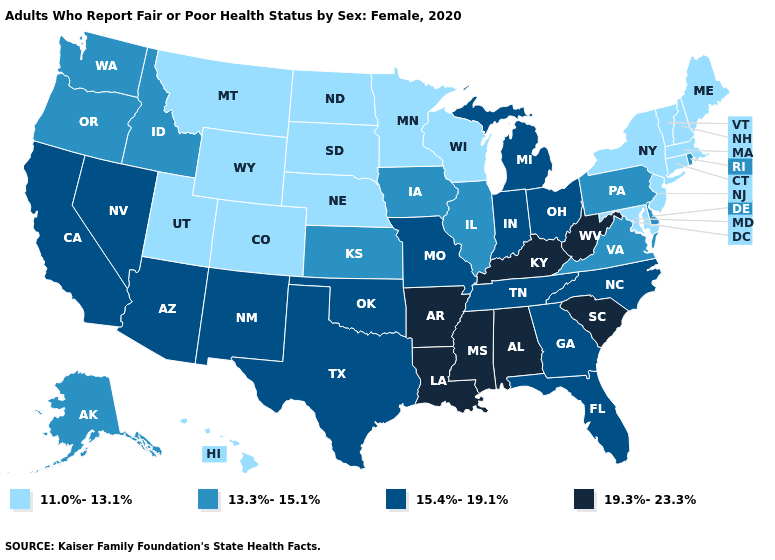Among the states that border Alabama , does Mississippi have the highest value?
Write a very short answer. Yes. Does Nebraska have the highest value in the USA?
Give a very brief answer. No. Does Rhode Island have the highest value in the Northeast?
Be succinct. Yes. What is the highest value in states that border Tennessee?
Quick response, please. 19.3%-23.3%. Does South Carolina have the highest value in the South?
Be succinct. Yes. Which states have the lowest value in the West?
Concise answer only. Colorado, Hawaii, Montana, Utah, Wyoming. What is the highest value in the West ?
Write a very short answer. 15.4%-19.1%. What is the highest value in the Northeast ?
Give a very brief answer. 13.3%-15.1%. Name the states that have a value in the range 19.3%-23.3%?
Answer briefly. Alabama, Arkansas, Kentucky, Louisiana, Mississippi, South Carolina, West Virginia. How many symbols are there in the legend?
Write a very short answer. 4. Name the states that have a value in the range 19.3%-23.3%?
Quick response, please. Alabama, Arkansas, Kentucky, Louisiana, Mississippi, South Carolina, West Virginia. Name the states that have a value in the range 19.3%-23.3%?
Short answer required. Alabama, Arkansas, Kentucky, Louisiana, Mississippi, South Carolina, West Virginia. Name the states that have a value in the range 19.3%-23.3%?
Give a very brief answer. Alabama, Arkansas, Kentucky, Louisiana, Mississippi, South Carolina, West Virginia. What is the highest value in states that border New Hampshire?
Answer briefly. 11.0%-13.1%. Name the states that have a value in the range 13.3%-15.1%?
Concise answer only. Alaska, Delaware, Idaho, Illinois, Iowa, Kansas, Oregon, Pennsylvania, Rhode Island, Virginia, Washington. 